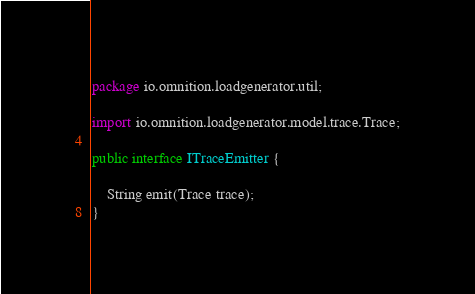Convert code to text. <code><loc_0><loc_0><loc_500><loc_500><_Java_>package io.omnition.loadgenerator.util;

import io.omnition.loadgenerator.model.trace.Trace;

public interface ITraceEmitter {

    String emit(Trace trace);
}
</code> 